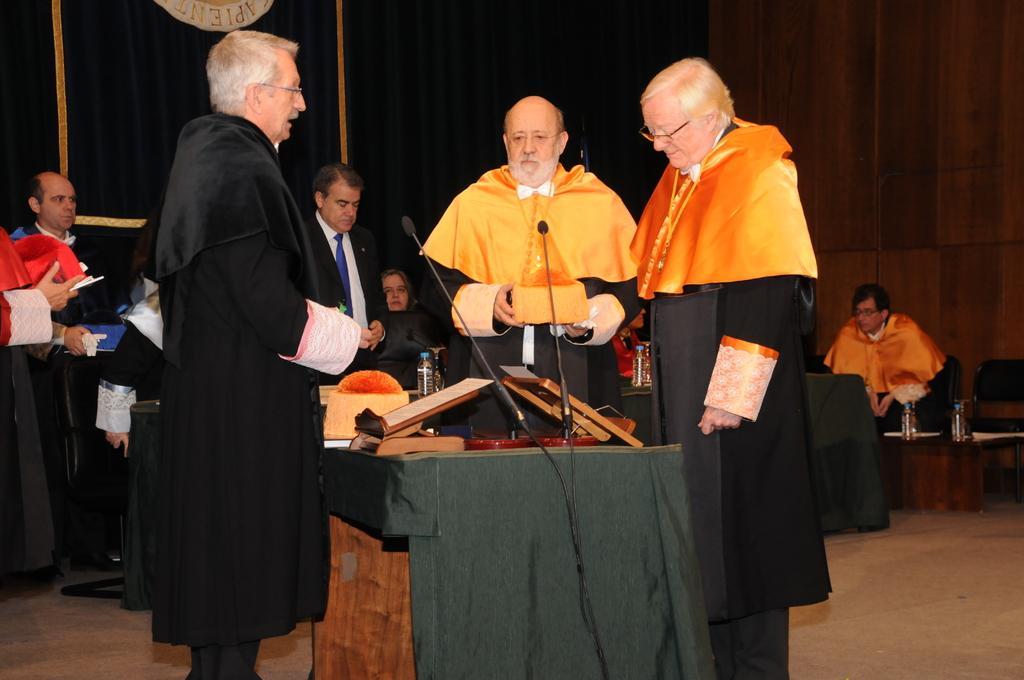Can you describe this image briefly? In this image there is a person standing in front of the table. On top of it there are mikes and a few other objects. Beside him there are a few other people standing on the floor. In the background of the image there are people sitting on the chairs. There are tables. On top of it there are water bottles. There are curtains. There is a wall. 